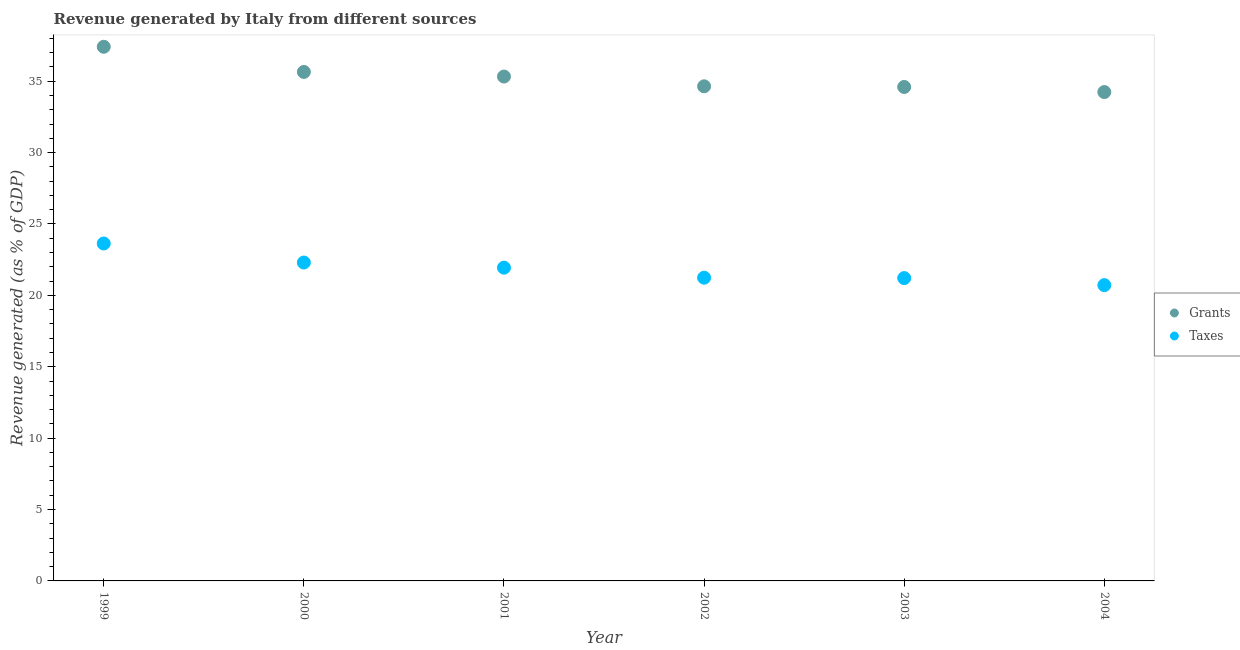Is the number of dotlines equal to the number of legend labels?
Offer a terse response. Yes. What is the revenue generated by grants in 2004?
Keep it short and to the point. 34.24. Across all years, what is the maximum revenue generated by grants?
Your answer should be compact. 37.41. Across all years, what is the minimum revenue generated by taxes?
Offer a terse response. 20.72. In which year was the revenue generated by grants maximum?
Your answer should be very brief. 1999. What is the total revenue generated by taxes in the graph?
Make the answer very short. 131.05. What is the difference between the revenue generated by grants in 1999 and that in 2000?
Offer a very short reply. 1.76. What is the difference between the revenue generated by grants in 2003 and the revenue generated by taxes in 2002?
Make the answer very short. 13.36. What is the average revenue generated by taxes per year?
Your answer should be very brief. 21.84. In the year 2000, what is the difference between the revenue generated by grants and revenue generated by taxes?
Offer a terse response. 13.35. What is the ratio of the revenue generated by grants in 2000 to that in 2004?
Your answer should be compact. 1.04. What is the difference between the highest and the second highest revenue generated by grants?
Provide a short and direct response. 1.76. What is the difference between the highest and the lowest revenue generated by taxes?
Offer a very short reply. 2.92. Is the sum of the revenue generated by grants in 1999 and 2004 greater than the maximum revenue generated by taxes across all years?
Provide a succinct answer. Yes. Does the revenue generated by grants monotonically increase over the years?
Make the answer very short. No. Is the revenue generated by taxes strictly less than the revenue generated by grants over the years?
Provide a short and direct response. Yes. How many years are there in the graph?
Your answer should be compact. 6. Are the values on the major ticks of Y-axis written in scientific E-notation?
Your answer should be compact. No. Does the graph contain any zero values?
Ensure brevity in your answer.  No. Where does the legend appear in the graph?
Offer a terse response. Center right. How many legend labels are there?
Provide a succinct answer. 2. What is the title of the graph?
Ensure brevity in your answer.  Revenue generated by Italy from different sources. What is the label or title of the X-axis?
Ensure brevity in your answer.  Year. What is the label or title of the Y-axis?
Keep it short and to the point. Revenue generated (as % of GDP). What is the Revenue generated (as % of GDP) in Grants in 1999?
Make the answer very short. 37.41. What is the Revenue generated (as % of GDP) in Taxes in 1999?
Your response must be concise. 23.63. What is the Revenue generated (as % of GDP) in Grants in 2000?
Your response must be concise. 35.65. What is the Revenue generated (as % of GDP) in Taxes in 2000?
Offer a terse response. 22.3. What is the Revenue generated (as % of GDP) in Grants in 2001?
Your response must be concise. 35.33. What is the Revenue generated (as % of GDP) of Taxes in 2001?
Offer a very short reply. 21.94. What is the Revenue generated (as % of GDP) in Grants in 2002?
Your response must be concise. 34.64. What is the Revenue generated (as % of GDP) of Taxes in 2002?
Make the answer very short. 21.24. What is the Revenue generated (as % of GDP) of Grants in 2003?
Keep it short and to the point. 34.6. What is the Revenue generated (as % of GDP) of Taxes in 2003?
Your answer should be very brief. 21.21. What is the Revenue generated (as % of GDP) of Grants in 2004?
Give a very brief answer. 34.24. What is the Revenue generated (as % of GDP) in Taxes in 2004?
Offer a very short reply. 20.72. Across all years, what is the maximum Revenue generated (as % of GDP) in Grants?
Your answer should be compact. 37.41. Across all years, what is the maximum Revenue generated (as % of GDP) of Taxes?
Your response must be concise. 23.63. Across all years, what is the minimum Revenue generated (as % of GDP) of Grants?
Provide a short and direct response. 34.24. Across all years, what is the minimum Revenue generated (as % of GDP) of Taxes?
Offer a terse response. 20.72. What is the total Revenue generated (as % of GDP) in Grants in the graph?
Your answer should be compact. 211.87. What is the total Revenue generated (as % of GDP) in Taxes in the graph?
Offer a terse response. 131.05. What is the difference between the Revenue generated (as % of GDP) of Grants in 1999 and that in 2000?
Your answer should be compact. 1.76. What is the difference between the Revenue generated (as % of GDP) of Taxes in 1999 and that in 2000?
Your response must be concise. 1.33. What is the difference between the Revenue generated (as % of GDP) of Grants in 1999 and that in 2001?
Offer a terse response. 2.08. What is the difference between the Revenue generated (as % of GDP) in Taxes in 1999 and that in 2001?
Offer a very short reply. 1.69. What is the difference between the Revenue generated (as % of GDP) of Grants in 1999 and that in 2002?
Your answer should be very brief. 2.77. What is the difference between the Revenue generated (as % of GDP) in Taxes in 1999 and that in 2002?
Give a very brief answer. 2.4. What is the difference between the Revenue generated (as % of GDP) of Grants in 1999 and that in 2003?
Your answer should be very brief. 2.81. What is the difference between the Revenue generated (as % of GDP) of Taxes in 1999 and that in 2003?
Provide a short and direct response. 2.42. What is the difference between the Revenue generated (as % of GDP) in Grants in 1999 and that in 2004?
Keep it short and to the point. 3.17. What is the difference between the Revenue generated (as % of GDP) of Taxes in 1999 and that in 2004?
Offer a terse response. 2.92. What is the difference between the Revenue generated (as % of GDP) of Grants in 2000 and that in 2001?
Offer a terse response. 0.32. What is the difference between the Revenue generated (as % of GDP) in Taxes in 2000 and that in 2001?
Keep it short and to the point. 0.36. What is the difference between the Revenue generated (as % of GDP) of Taxes in 2000 and that in 2002?
Ensure brevity in your answer.  1.06. What is the difference between the Revenue generated (as % of GDP) in Grants in 2000 and that in 2003?
Provide a short and direct response. 1.05. What is the difference between the Revenue generated (as % of GDP) in Taxes in 2000 and that in 2003?
Keep it short and to the point. 1.09. What is the difference between the Revenue generated (as % of GDP) of Grants in 2000 and that in 2004?
Provide a succinct answer. 1.41. What is the difference between the Revenue generated (as % of GDP) of Taxes in 2000 and that in 2004?
Give a very brief answer. 1.58. What is the difference between the Revenue generated (as % of GDP) in Grants in 2001 and that in 2002?
Offer a terse response. 0.68. What is the difference between the Revenue generated (as % of GDP) of Taxes in 2001 and that in 2002?
Your answer should be very brief. 0.7. What is the difference between the Revenue generated (as % of GDP) in Grants in 2001 and that in 2003?
Your answer should be compact. 0.73. What is the difference between the Revenue generated (as % of GDP) in Taxes in 2001 and that in 2003?
Your response must be concise. 0.73. What is the difference between the Revenue generated (as % of GDP) in Grants in 2001 and that in 2004?
Offer a very short reply. 1.09. What is the difference between the Revenue generated (as % of GDP) in Taxes in 2001 and that in 2004?
Provide a succinct answer. 1.22. What is the difference between the Revenue generated (as % of GDP) in Grants in 2002 and that in 2003?
Ensure brevity in your answer.  0.04. What is the difference between the Revenue generated (as % of GDP) of Taxes in 2002 and that in 2003?
Give a very brief answer. 0.03. What is the difference between the Revenue generated (as % of GDP) in Grants in 2002 and that in 2004?
Provide a succinct answer. 0.4. What is the difference between the Revenue generated (as % of GDP) in Taxes in 2002 and that in 2004?
Provide a succinct answer. 0.52. What is the difference between the Revenue generated (as % of GDP) of Grants in 2003 and that in 2004?
Give a very brief answer. 0.36. What is the difference between the Revenue generated (as % of GDP) in Taxes in 2003 and that in 2004?
Your answer should be compact. 0.49. What is the difference between the Revenue generated (as % of GDP) in Grants in 1999 and the Revenue generated (as % of GDP) in Taxes in 2000?
Offer a very short reply. 15.11. What is the difference between the Revenue generated (as % of GDP) of Grants in 1999 and the Revenue generated (as % of GDP) of Taxes in 2001?
Give a very brief answer. 15.47. What is the difference between the Revenue generated (as % of GDP) of Grants in 1999 and the Revenue generated (as % of GDP) of Taxes in 2002?
Your answer should be very brief. 16.17. What is the difference between the Revenue generated (as % of GDP) of Grants in 1999 and the Revenue generated (as % of GDP) of Taxes in 2003?
Give a very brief answer. 16.2. What is the difference between the Revenue generated (as % of GDP) in Grants in 1999 and the Revenue generated (as % of GDP) in Taxes in 2004?
Your response must be concise. 16.69. What is the difference between the Revenue generated (as % of GDP) in Grants in 2000 and the Revenue generated (as % of GDP) in Taxes in 2001?
Keep it short and to the point. 13.71. What is the difference between the Revenue generated (as % of GDP) in Grants in 2000 and the Revenue generated (as % of GDP) in Taxes in 2002?
Make the answer very short. 14.41. What is the difference between the Revenue generated (as % of GDP) in Grants in 2000 and the Revenue generated (as % of GDP) in Taxes in 2003?
Offer a very short reply. 14.44. What is the difference between the Revenue generated (as % of GDP) of Grants in 2000 and the Revenue generated (as % of GDP) of Taxes in 2004?
Your answer should be very brief. 14.93. What is the difference between the Revenue generated (as % of GDP) in Grants in 2001 and the Revenue generated (as % of GDP) in Taxes in 2002?
Your response must be concise. 14.09. What is the difference between the Revenue generated (as % of GDP) of Grants in 2001 and the Revenue generated (as % of GDP) of Taxes in 2003?
Ensure brevity in your answer.  14.12. What is the difference between the Revenue generated (as % of GDP) of Grants in 2001 and the Revenue generated (as % of GDP) of Taxes in 2004?
Provide a short and direct response. 14.61. What is the difference between the Revenue generated (as % of GDP) of Grants in 2002 and the Revenue generated (as % of GDP) of Taxes in 2003?
Offer a very short reply. 13.43. What is the difference between the Revenue generated (as % of GDP) in Grants in 2002 and the Revenue generated (as % of GDP) in Taxes in 2004?
Ensure brevity in your answer.  13.93. What is the difference between the Revenue generated (as % of GDP) of Grants in 2003 and the Revenue generated (as % of GDP) of Taxes in 2004?
Your answer should be compact. 13.88. What is the average Revenue generated (as % of GDP) in Grants per year?
Make the answer very short. 35.31. What is the average Revenue generated (as % of GDP) in Taxes per year?
Provide a short and direct response. 21.84. In the year 1999, what is the difference between the Revenue generated (as % of GDP) of Grants and Revenue generated (as % of GDP) of Taxes?
Your answer should be very brief. 13.78. In the year 2000, what is the difference between the Revenue generated (as % of GDP) in Grants and Revenue generated (as % of GDP) in Taxes?
Ensure brevity in your answer.  13.35. In the year 2001, what is the difference between the Revenue generated (as % of GDP) in Grants and Revenue generated (as % of GDP) in Taxes?
Your answer should be compact. 13.39. In the year 2002, what is the difference between the Revenue generated (as % of GDP) of Grants and Revenue generated (as % of GDP) of Taxes?
Your answer should be compact. 13.4. In the year 2003, what is the difference between the Revenue generated (as % of GDP) of Grants and Revenue generated (as % of GDP) of Taxes?
Give a very brief answer. 13.39. In the year 2004, what is the difference between the Revenue generated (as % of GDP) in Grants and Revenue generated (as % of GDP) in Taxes?
Offer a terse response. 13.52. What is the ratio of the Revenue generated (as % of GDP) in Grants in 1999 to that in 2000?
Keep it short and to the point. 1.05. What is the ratio of the Revenue generated (as % of GDP) in Taxes in 1999 to that in 2000?
Give a very brief answer. 1.06. What is the ratio of the Revenue generated (as % of GDP) in Grants in 1999 to that in 2001?
Keep it short and to the point. 1.06. What is the ratio of the Revenue generated (as % of GDP) in Taxes in 1999 to that in 2001?
Keep it short and to the point. 1.08. What is the ratio of the Revenue generated (as % of GDP) of Grants in 1999 to that in 2002?
Provide a short and direct response. 1.08. What is the ratio of the Revenue generated (as % of GDP) in Taxes in 1999 to that in 2002?
Your response must be concise. 1.11. What is the ratio of the Revenue generated (as % of GDP) of Grants in 1999 to that in 2003?
Offer a very short reply. 1.08. What is the ratio of the Revenue generated (as % of GDP) of Taxes in 1999 to that in 2003?
Offer a terse response. 1.11. What is the ratio of the Revenue generated (as % of GDP) in Grants in 1999 to that in 2004?
Make the answer very short. 1.09. What is the ratio of the Revenue generated (as % of GDP) of Taxes in 1999 to that in 2004?
Provide a short and direct response. 1.14. What is the ratio of the Revenue generated (as % of GDP) of Grants in 2000 to that in 2001?
Your answer should be compact. 1.01. What is the ratio of the Revenue generated (as % of GDP) of Taxes in 2000 to that in 2001?
Keep it short and to the point. 1.02. What is the ratio of the Revenue generated (as % of GDP) in Taxes in 2000 to that in 2002?
Provide a short and direct response. 1.05. What is the ratio of the Revenue generated (as % of GDP) of Grants in 2000 to that in 2003?
Your answer should be compact. 1.03. What is the ratio of the Revenue generated (as % of GDP) of Taxes in 2000 to that in 2003?
Keep it short and to the point. 1.05. What is the ratio of the Revenue generated (as % of GDP) in Grants in 2000 to that in 2004?
Keep it short and to the point. 1.04. What is the ratio of the Revenue generated (as % of GDP) of Taxes in 2000 to that in 2004?
Your answer should be very brief. 1.08. What is the ratio of the Revenue generated (as % of GDP) in Grants in 2001 to that in 2002?
Keep it short and to the point. 1.02. What is the ratio of the Revenue generated (as % of GDP) in Taxes in 2001 to that in 2002?
Keep it short and to the point. 1.03. What is the ratio of the Revenue generated (as % of GDP) of Grants in 2001 to that in 2003?
Offer a terse response. 1.02. What is the ratio of the Revenue generated (as % of GDP) of Taxes in 2001 to that in 2003?
Make the answer very short. 1.03. What is the ratio of the Revenue generated (as % of GDP) of Grants in 2001 to that in 2004?
Offer a terse response. 1.03. What is the ratio of the Revenue generated (as % of GDP) of Taxes in 2001 to that in 2004?
Keep it short and to the point. 1.06. What is the ratio of the Revenue generated (as % of GDP) of Taxes in 2002 to that in 2003?
Offer a terse response. 1. What is the ratio of the Revenue generated (as % of GDP) of Grants in 2002 to that in 2004?
Keep it short and to the point. 1.01. What is the ratio of the Revenue generated (as % of GDP) in Taxes in 2002 to that in 2004?
Provide a succinct answer. 1.03. What is the ratio of the Revenue generated (as % of GDP) of Grants in 2003 to that in 2004?
Keep it short and to the point. 1.01. What is the ratio of the Revenue generated (as % of GDP) of Taxes in 2003 to that in 2004?
Keep it short and to the point. 1.02. What is the difference between the highest and the second highest Revenue generated (as % of GDP) in Grants?
Your answer should be compact. 1.76. What is the difference between the highest and the second highest Revenue generated (as % of GDP) of Taxes?
Ensure brevity in your answer.  1.33. What is the difference between the highest and the lowest Revenue generated (as % of GDP) of Grants?
Provide a succinct answer. 3.17. What is the difference between the highest and the lowest Revenue generated (as % of GDP) in Taxes?
Provide a succinct answer. 2.92. 